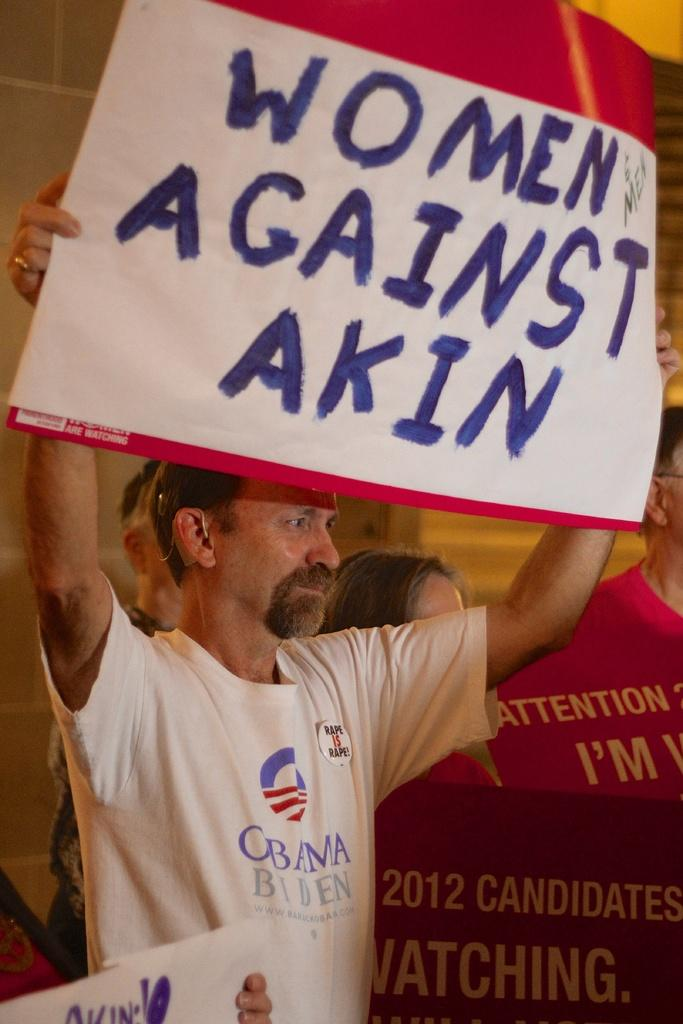<image>
Create a compact narrative representing the image presented. A man wearing an Obama Biden shirt holds up a sign that reads "Women Against Akin". 